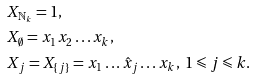<formula> <loc_0><loc_0><loc_500><loc_500>& X _ { \mathbb { N } _ { k } } = 1 , \\ & X _ { \emptyset } = x _ { 1 } x _ { 2 } \dots x _ { k } , \\ & X _ { j } = X _ { \{ j \} } = x _ { 1 } \dots \hat { x } _ { j } \dots x _ { k } , \ 1 \leqslant j \leqslant k .</formula> 